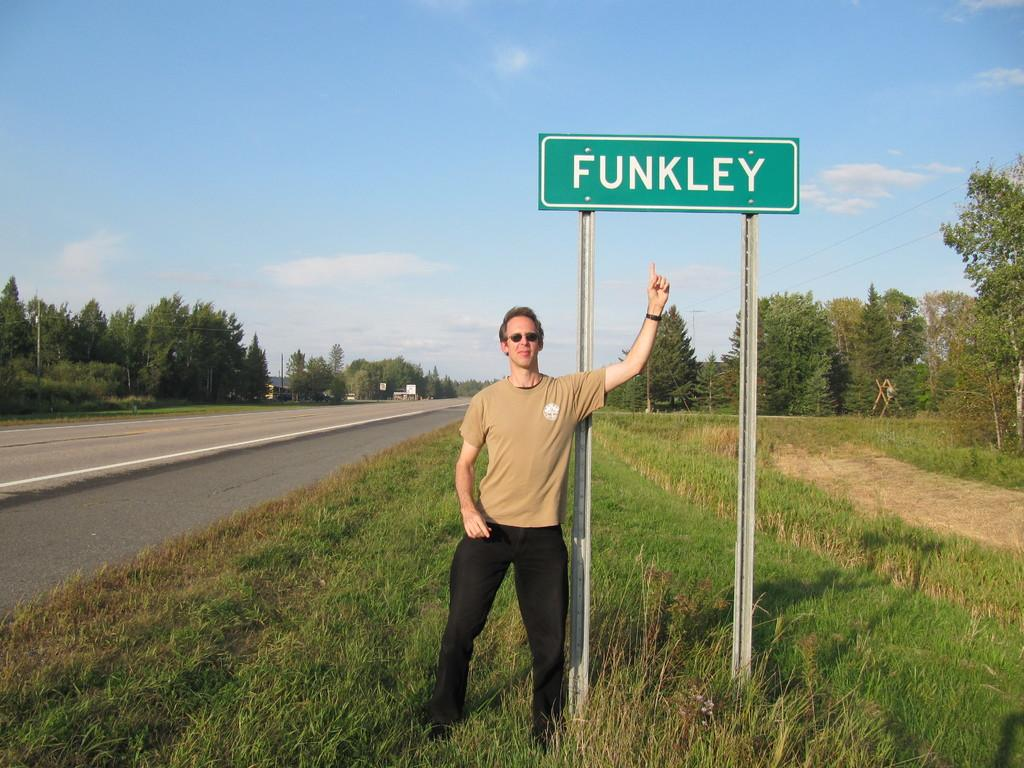What is the man in the image doing? The man is standing on the grass in the image. What can be seen in the background of the image? The sky is visible in the background of the image, and there are clouds in the sky. What type of surface is visible in the image? There is a road in the image. What other objects can be seen in the image? There are trees, poles, and a board in the image. What type of chin can be seen on the board in the image? There is no chin present on the board in the image. How many cakes are being looked at by the man in the image? There are no cakes visible in the image, and the man is not looking at any cakes. 